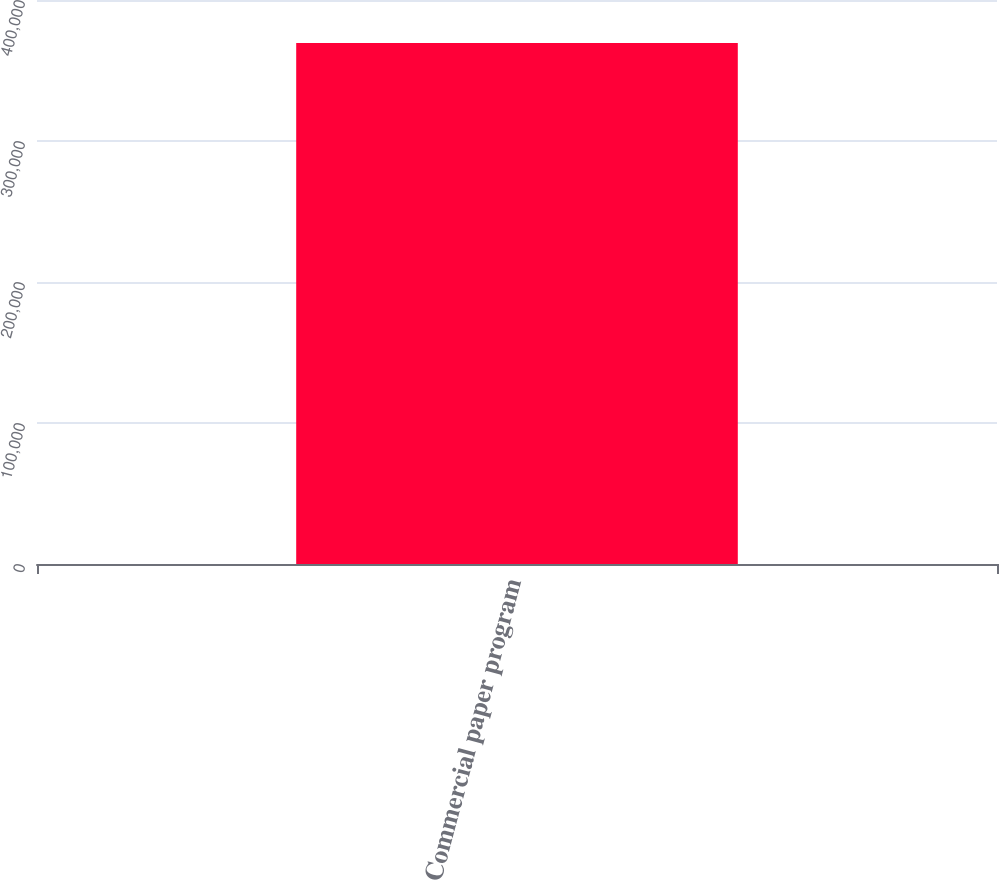<chart> <loc_0><loc_0><loc_500><loc_500><bar_chart><fcel>Commercial paper program<nl><fcel>369500<nl></chart> 